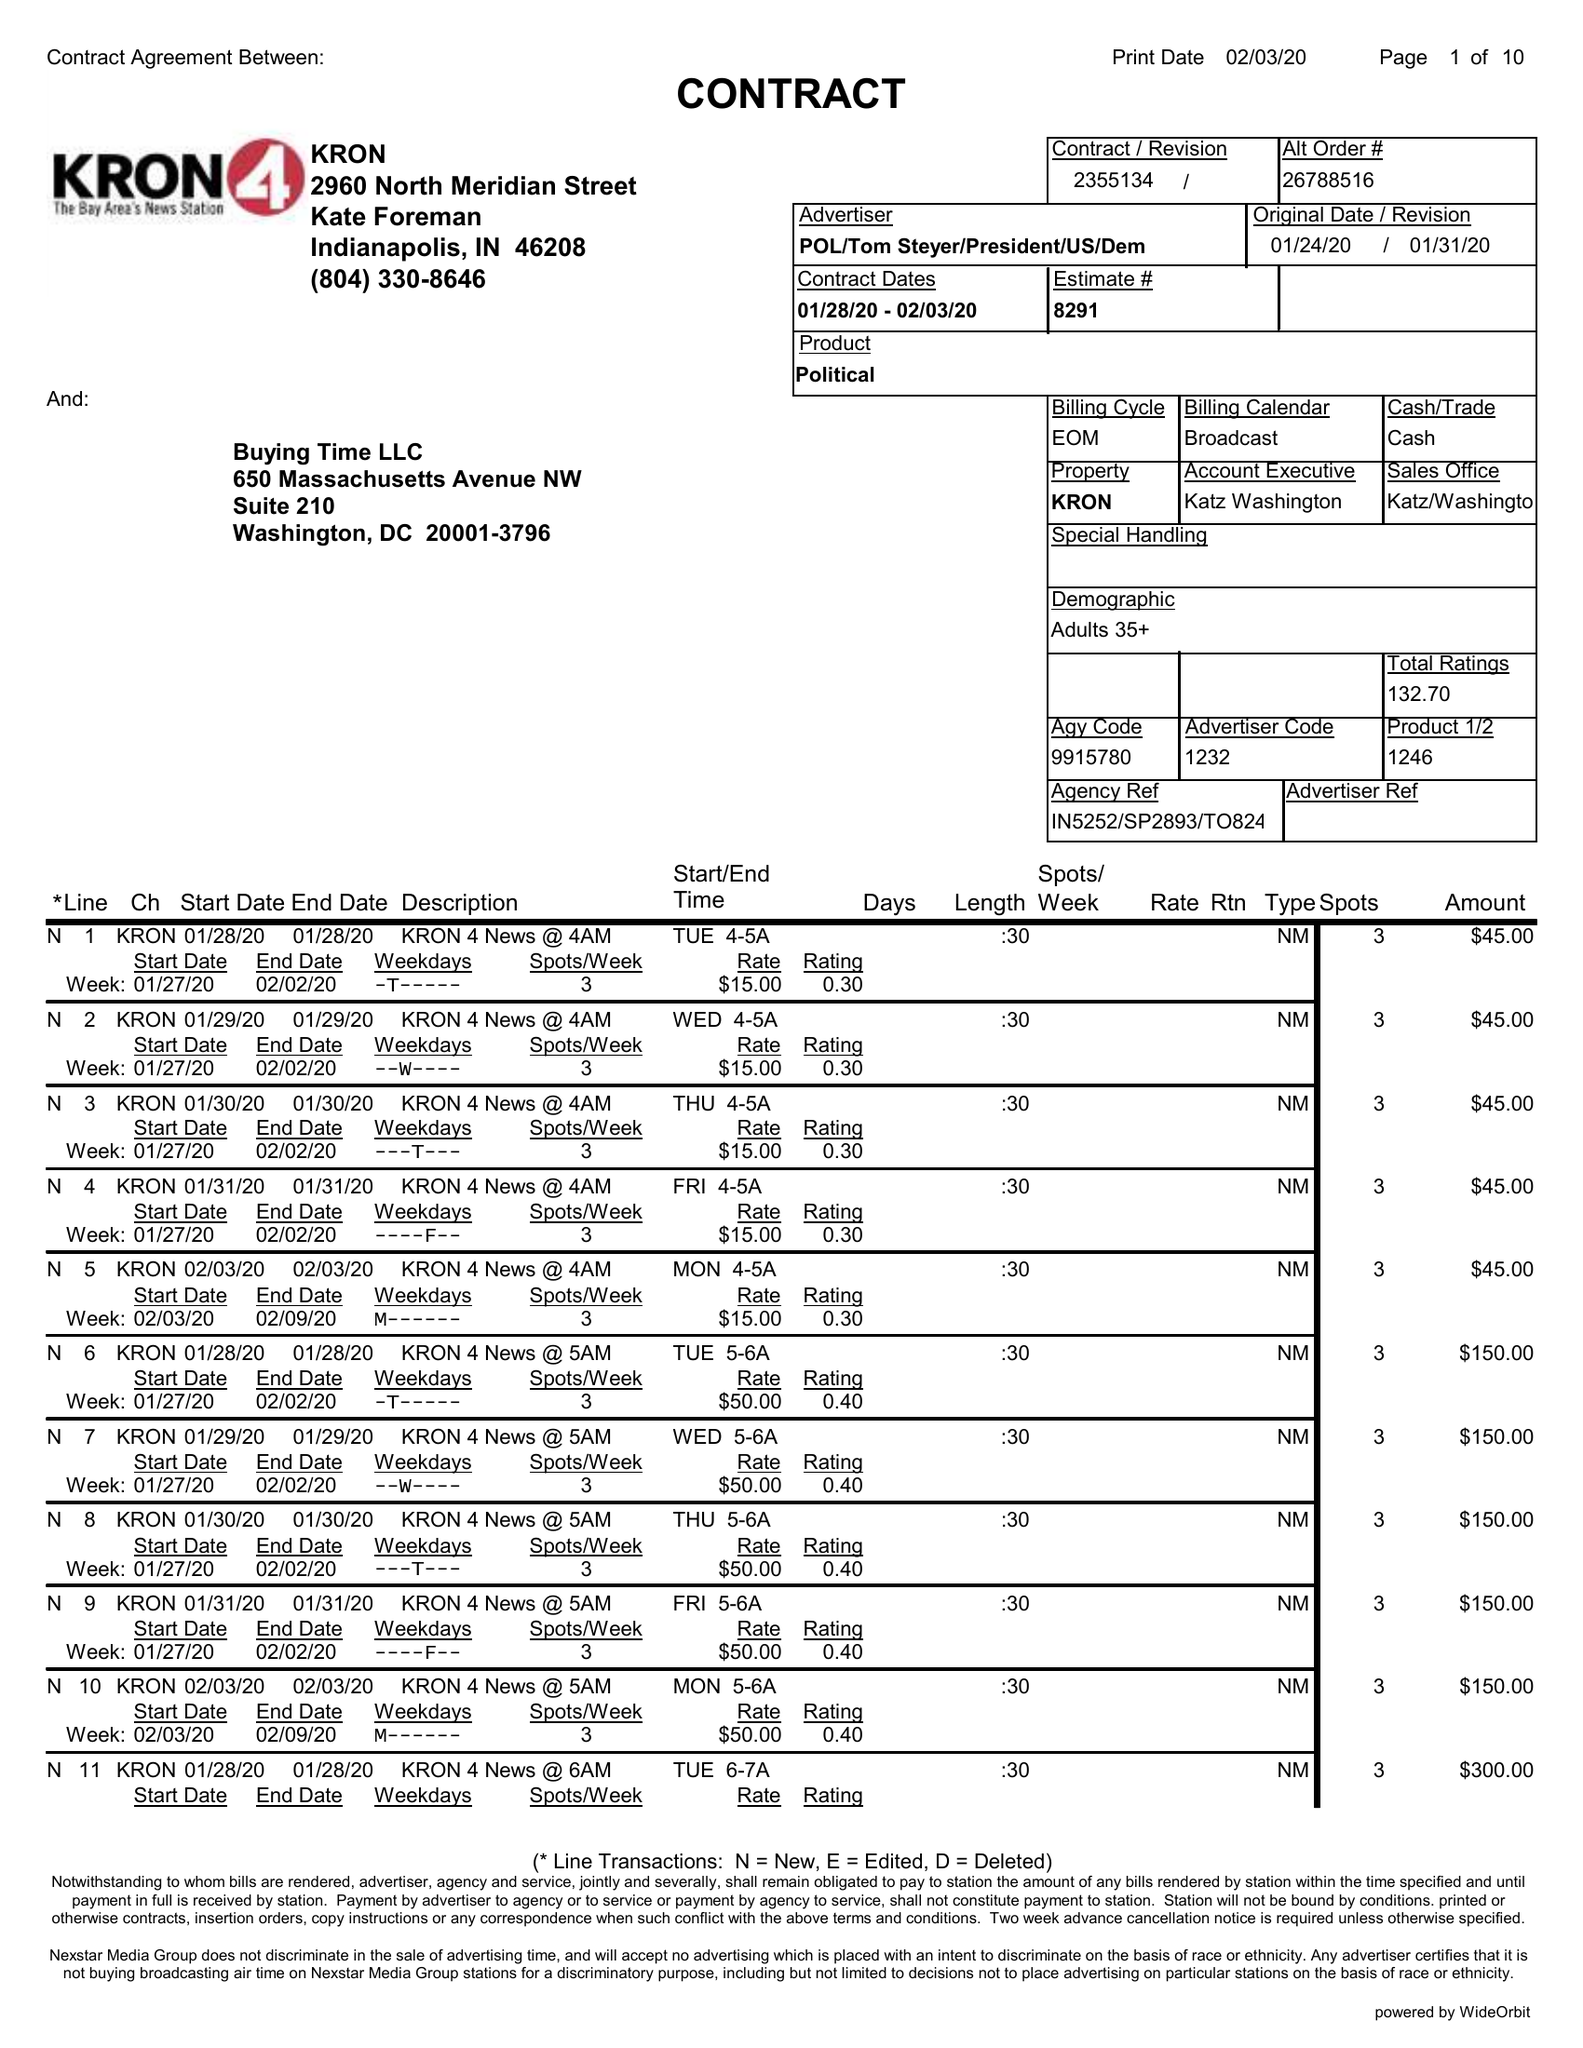What is the value for the flight_from?
Answer the question using a single word or phrase. 01/28/20 